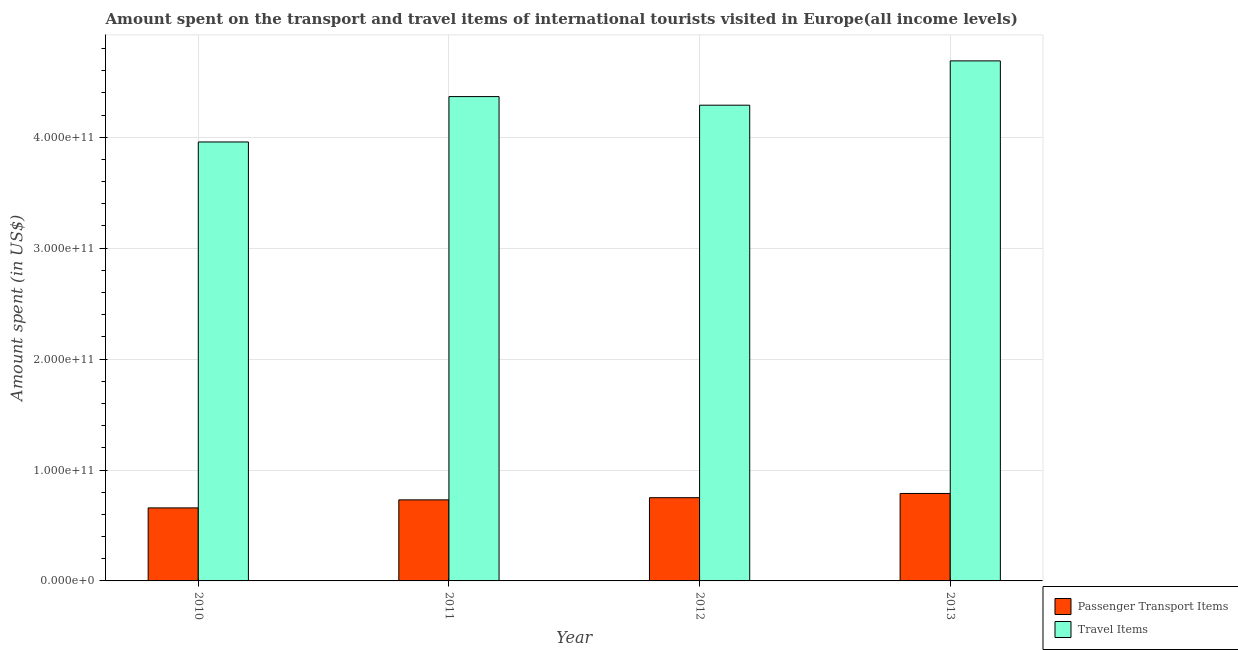How many groups of bars are there?
Keep it short and to the point. 4. What is the label of the 4th group of bars from the left?
Provide a short and direct response. 2013. What is the amount spent in travel items in 2012?
Provide a succinct answer. 4.29e+11. Across all years, what is the maximum amount spent on passenger transport items?
Give a very brief answer. 7.88e+1. Across all years, what is the minimum amount spent on passenger transport items?
Give a very brief answer. 6.58e+1. What is the total amount spent in travel items in the graph?
Your response must be concise. 1.73e+12. What is the difference between the amount spent in travel items in 2010 and that in 2013?
Provide a succinct answer. -7.31e+1. What is the difference between the amount spent on passenger transport items in 2012 and the amount spent in travel items in 2010?
Make the answer very short. 9.20e+09. What is the average amount spent on passenger transport items per year?
Offer a terse response. 7.32e+1. In the year 2010, what is the difference between the amount spent on passenger transport items and amount spent in travel items?
Offer a terse response. 0. In how many years, is the amount spent in travel items greater than 100000000000 US$?
Offer a terse response. 4. What is the ratio of the amount spent on passenger transport items in 2010 to that in 2013?
Ensure brevity in your answer.  0.83. Is the amount spent in travel items in 2010 less than that in 2012?
Offer a very short reply. Yes. Is the difference between the amount spent on passenger transport items in 2010 and 2012 greater than the difference between the amount spent in travel items in 2010 and 2012?
Your response must be concise. No. What is the difference between the highest and the second highest amount spent on passenger transport items?
Offer a terse response. 3.82e+09. What is the difference between the highest and the lowest amount spent in travel items?
Offer a very short reply. 7.31e+1. In how many years, is the amount spent on passenger transport items greater than the average amount spent on passenger transport items taken over all years?
Provide a short and direct response. 2. Is the sum of the amount spent in travel items in 2010 and 2012 greater than the maximum amount spent on passenger transport items across all years?
Your answer should be compact. Yes. What does the 1st bar from the left in 2010 represents?
Offer a very short reply. Passenger Transport Items. What does the 2nd bar from the right in 2013 represents?
Your answer should be compact. Passenger Transport Items. What is the difference between two consecutive major ticks on the Y-axis?
Make the answer very short. 1.00e+11. Are the values on the major ticks of Y-axis written in scientific E-notation?
Your response must be concise. Yes. What is the title of the graph?
Offer a very short reply. Amount spent on the transport and travel items of international tourists visited in Europe(all income levels). What is the label or title of the X-axis?
Offer a terse response. Year. What is the label or title of the Y-axis?
Ensure brevity in your answer.  Amount spent (in US$). What is the Amount spent (in US$) in Passenger Transport Items in 2010?
Your answer should be compact. 6.58e+1. What is the Amount spent (in US$) of Travel Items in 2010?
Ensure brevity in your answer.  3.96e+11. What is the Amount spent (in US$) of Passenger Transport Items in 2011?
Provide a short and direct response. 7.31e+1. What is the Amount spent (in US$) in Travel Items in 2011?
Offer a terse response. 4.37e+11. What is the Amount spent (in US$) in Passenger Transport Items in 2012?
Give a very brief answer. 7.50e+1. What is the Amount spent (in US$) in Travel Items in 2012?
Give a very brief answer. 4.29e+11. What is the Amount spent (in US$) in Passenger Transport Items in 2013?
Offer a terse response. 7.88e+1. What is the Amount spent (in US$) in Travel Items in 2013?
Make the answer very short. 4.69e+11. Across all years, what is the maximum Amount spent (in US$) in Passenger Transport Items?
Keep it short and to the point. 7.88e+1. Across all years, what is the maximum Amount spent (in US$) of Travel Items?
Offer a terse response. 4.69e+11. Across all years, what is the minimum Amount spent (in US$) of Passenger Transport Items?
Provide a short and direct response. 6.58e+1. Across all years, what is the minimum Amount spent (in US$) of Travel Items?
Your response must be concise. 3.96e+11. What is the total Amount spent (in US$) of Passenger Transport Items in the graph?
Offer a very short reply. 2.93e+11. What is the total Amount spent (in US$) of Travel Items in the graph?
Your response must be concise. 1.73e+12. What is the difference between the Amount spent (in US$) of Passenger Transport Items in 2010 and that in 2011?
Your answer should be very brief. -7.23e+09. What is the difference between the Amount spent (in US$) in Travel Items in 2010 and that in 2011?
Provide a succinct answer. -4.09e+1. What is the difference between the Amount spent (in US$) of Passenger Transport Items in 2010 and that in 2012?
Provide a short and direct response. -9.20e+09. What is the difference between the Amount spent (in US$) in Travel Items in 2010 and that in 2012?
Provide a short and direct response. -3.31e+1. What is the difference between the Amount spent (in US$) in Passenger Transport Items in 2010 and that in 2013?
Your answer should be compact. -1.30e+1. What is the difference between the Amount spent (in US$) in Travel Items in 2010 and that in 2013?
Provide a succinct answer. -7.31e+1. What is the difference between the Amount spent (in US$) of Passenger Transport Items in 2011 and that in 2012?
Make the answer very short. -1.97e+09. What is the difference between the Amount spent (in US$) of Travel Items in 2011 and that in 2012?
Offer a terse response. 7.77e+09. What is the difference between the Amount spent (in US$) of Passenger Transport Items in 2011 and that in 2013?
Your response must be concise. -5.78e+09. What is the difference between the Amount spent (in US$) in Travel Items in 2011 and that in 2013?
Ensure brevity in your answer.  -3.22e+1. What is the difference between the Amount spent (in US$) of Passenger Transport Items in 2012 and that in 2013?
Provide a succinct answer. -3.82e+09. What is the difference between the Amount spent (in US$) in Travel Items in 2012 and that in 2013?
Your answer should be compact. -4.00e+1. What is the difference between the Amount spent (in US$) in Passenger Transport Items in 2010 and the Amount spent (in US$) in Travel Items in 2011?
Your response must be concise. -3.71e+11. What is the difference between the Amount spent (in US$) of Passenger Transport Items in 2010 and the Amount spent (in US$) of Travel Items in 2012?
Provide a short and direct response. -3.63e+11. What is the difference between the Amount spent (in US$) in Passenger Transport Items in 2010 and the Amount spent (in US$) in Travel Items in 2013?
Offer a terse response. -4.03e+11. What is the difference between the Amount spent (in US$) of Passenger Transport Items in 2011 and the Amount spent (in US$) of Travel Items in 2012?
Ensure brevity in your answer.  -3.56e+11. What is the difference between the Amount spent (in US$) in Passenger Transport Items in 2011 and the Amount spent (in US$) in Travel Items in 2013?
Your answer should be compact. -3.96e+11. What is the difference between the Amount spent (in US$) of Passenger Transport Items in 2012 and the Amount spent (in US$) of Travel Items in 2013?
Offer a very short reply. -3.94e+11. What is the average Amount spent (in US$) of Passenger Transport Items per year?
Your answer should be compact. 7.32e+1. What is the average Amount spent (in US$) of Travel Items per year?
Ensure brevity in your answer.  4.33e+11. In the year 2010, what is the difference between the Amount spent (in US$) of Passenger Transport Items and Amount spent (in US$) of Travel Items?
Your answer should be compact. -3.30e+11. In the year 2011, what is the difference between the Amount spent (in US$) of Passenger Transport Items and Amount spent (in US$) of Travel Items?
Your answer should be very brief. -3.64e+11. In the year 2012, what is the difference between the Amount spent (in US$) of Passenger Transport Items and Amount spent (in US$) of Travel Items?
Your answer should be very brief. -3.54e+11. In the year 2013, what is the difference between the Amount spent (in US$) in Passenger Transport Items and Amount spent (in US$) in Travel Items?
Offer a terse response. -3.90e+11. What is the ratio of the Amount spent (in US$) of Passenger Transport Items in 2010 to that in 2011?
Your response must be concise. 0.9. What is the ratio of the Amount spent (in US$) in Travel Items in 2010 to that in 2011?
Provide a short and direct response. 0.91. What is the ratio of the Amount spent (in US$) in Passenger Transport Items in 2010 to that in 2012?
Make the answer very short. 0.88. What is the ratio of the Amount spent (in US$) of Travel Items in 2010 to that in 2012?
Ensure brevity in your answer.  0.92. What is the ratio of the Amount spent (in US$) of Passenger Transport Items in 2010 to that in 2013?
Offer a very short reply. 0.83. What is the ratio of the Amount spent (in US$) in Travel Items in 2010 to that in 2013?
Your response must be concise. 0.84. What is the ratio of the Amount spent (in US$) in Passenger Transport Items in 2011 to that in 2012?
Your response must be concise. 0.97. What is the ratio of the Amount spent (in US$) in Travel Items in 2011 to that in 2012?
Provide a short and direct response. 1.02. What is the ratio of the Amount spent (in US$) of Passenger Transport Items in 2011 to that in 2013?
Offer a very short reply. 0.93. What is the ratio of the Amount spent (in US$) in Travel Items in 2011 to that in 2013?
Make the answer very short. 0.93. What is the ratio of the Amount spent (in US$) of Passenger Transport Items in 2012 to that in 2013?
Your answer should be compact. 0.95. What is the ratio of the Amount spent (in US$) in Travel Items in 2012 to that in 2013?
Offer a terse response. 0.91. What is the difference between the highest and the second highest Amount spent (in US$) in Passenger Transport Items?
Keep it short and to the point. 3.82e+09. What is the difference between the highest and the second highest Amount spent (in US$) in Travel Items?
Ensure brevity in your answer.  3.22e+1. What is the difference between the highest and the lowest Amount spent (in US$) in Passenger Transport Items?
Provide a succinct answer. 1.30e+1. What is the difference between the highest and the lowest Amount spent (in US$) of Travel Items?
Your answer should be compact. 7.31e+1. 